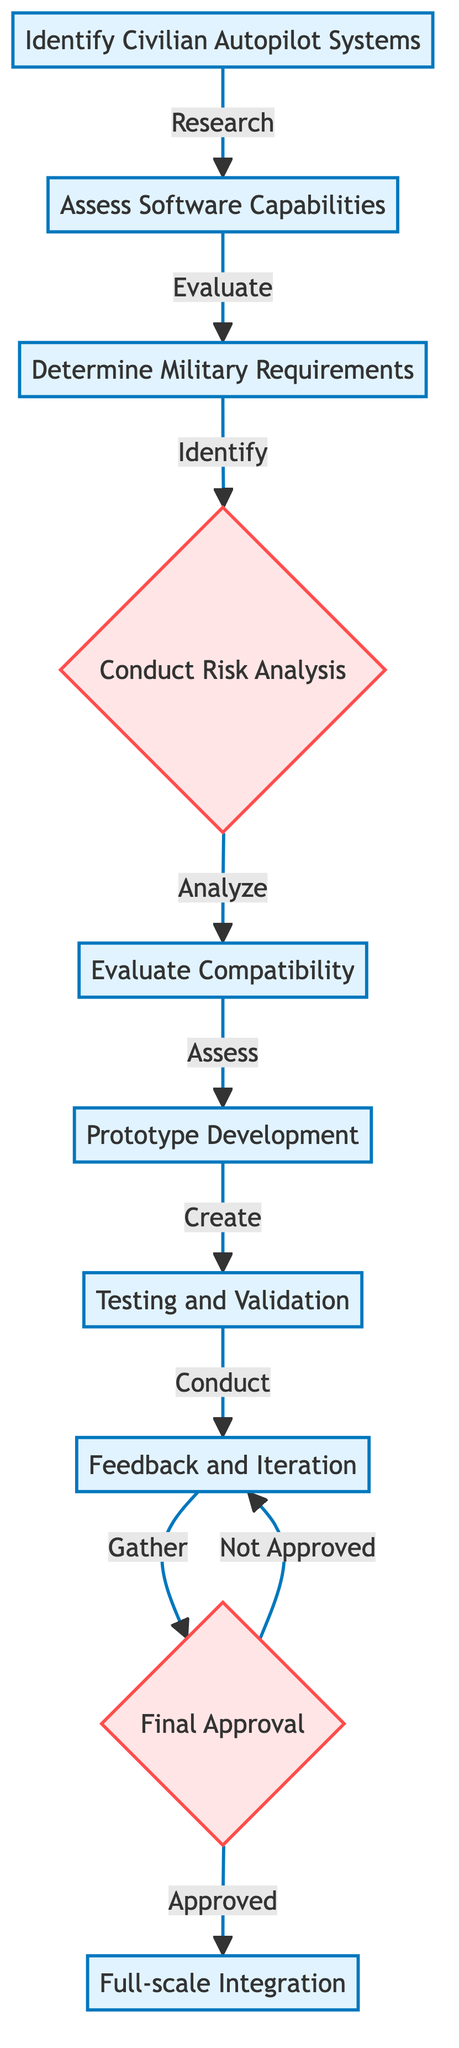What is the first step in the process? The diagram indicates that the first step is "Identify Civilian Autopilot Systems," as it is the starting node of the flow.
Answer: Identify Civilian Autopilot Systems How many main steps are there in total? By counting each of the process elements listed in the diagram, there are a total of 9 main steps present.
Answer: 9 What is evaluated after assessing software capabilities? Following the "Assess Software Capabilities" step, the next step is "Determine Military Requirements," which directly follows it in the flow.
Answer: Determine Military Requirements What type of analysis is conducted after determining military requirements? After determining military requirements, the process involves "Conduct Risk Analysis," which indicates another critical step in assessing the feasibility of integration.
Answer: Conduct Risk Analysis If the final approval is not granted, what should be the next step? If the "Final Approval" is not granted, as per the flowchart, the next step to take is "Feedback and Iteration" to revisit and improve the integration process.
Answer: Feedback and Iteration What is the outcome if the final approval is granted? The flowchart describes that if the "Final Approval" step is successful, the outcome will lead to "Full-scale Integration" of the civilian autopilot software into military aircraft.
Answer: Full-scale Integration Which decision step occurs after conducting a risk analysis? The decision step that follows "Conduct Risk Analysis" is "Evaluate Compatibility," which is where compatibility with military systems is assessed.
Answer: Evaluate Compatibility What key feature is prototyped after compatibility evaluation? After completing the "Evaluate Compatibility" step, the next stage is "Prototype Development," where a prototype integration of the software is created for further testing.
Answer: Prototype Development What is the last step in the flowchart? The last step depicted in the flowchart is "Full-scale Integration," which follows the decision of obtaining final approval.
Answer: Full-scale Integration 